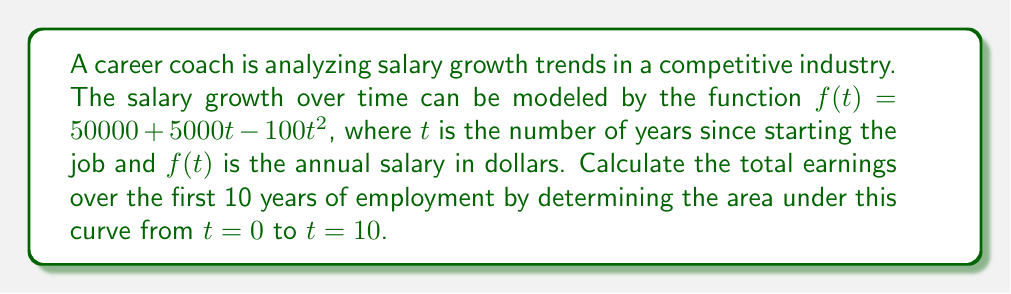Can you solve this math problem? To find the area under the curve, we need to integrate the function $f(t)$ from 0 to 10:

$$A = \int_0^{10} (50000 + 5000t - 100t^2) dt$$

Let's integrate each term separately:

1. $\int 50000 dt = 50000t$
2. $\int 5000t dt = 2500t^2$
3. $\int -100t^2 dt = -\frac{100}{3}t^3$

Now, we can combine these terms:

$$A = \left[50000t + 2500t^2 - \frac{100}{3}t^3\right]_0^{10}$$

Evaluating at the limits:

$$A = \left(500000 + 250000 - \frac{10000}{3}\right) - (0 + 0 - 0)$$

$$A = 750000 - \frac{10000}{3}$$

$$A = 750000 - 3333.33$$

$$A = 746666.67$$

Therefore, the total earnings over the first 10 years are $746,666.67.
Answer: $746,666.67 